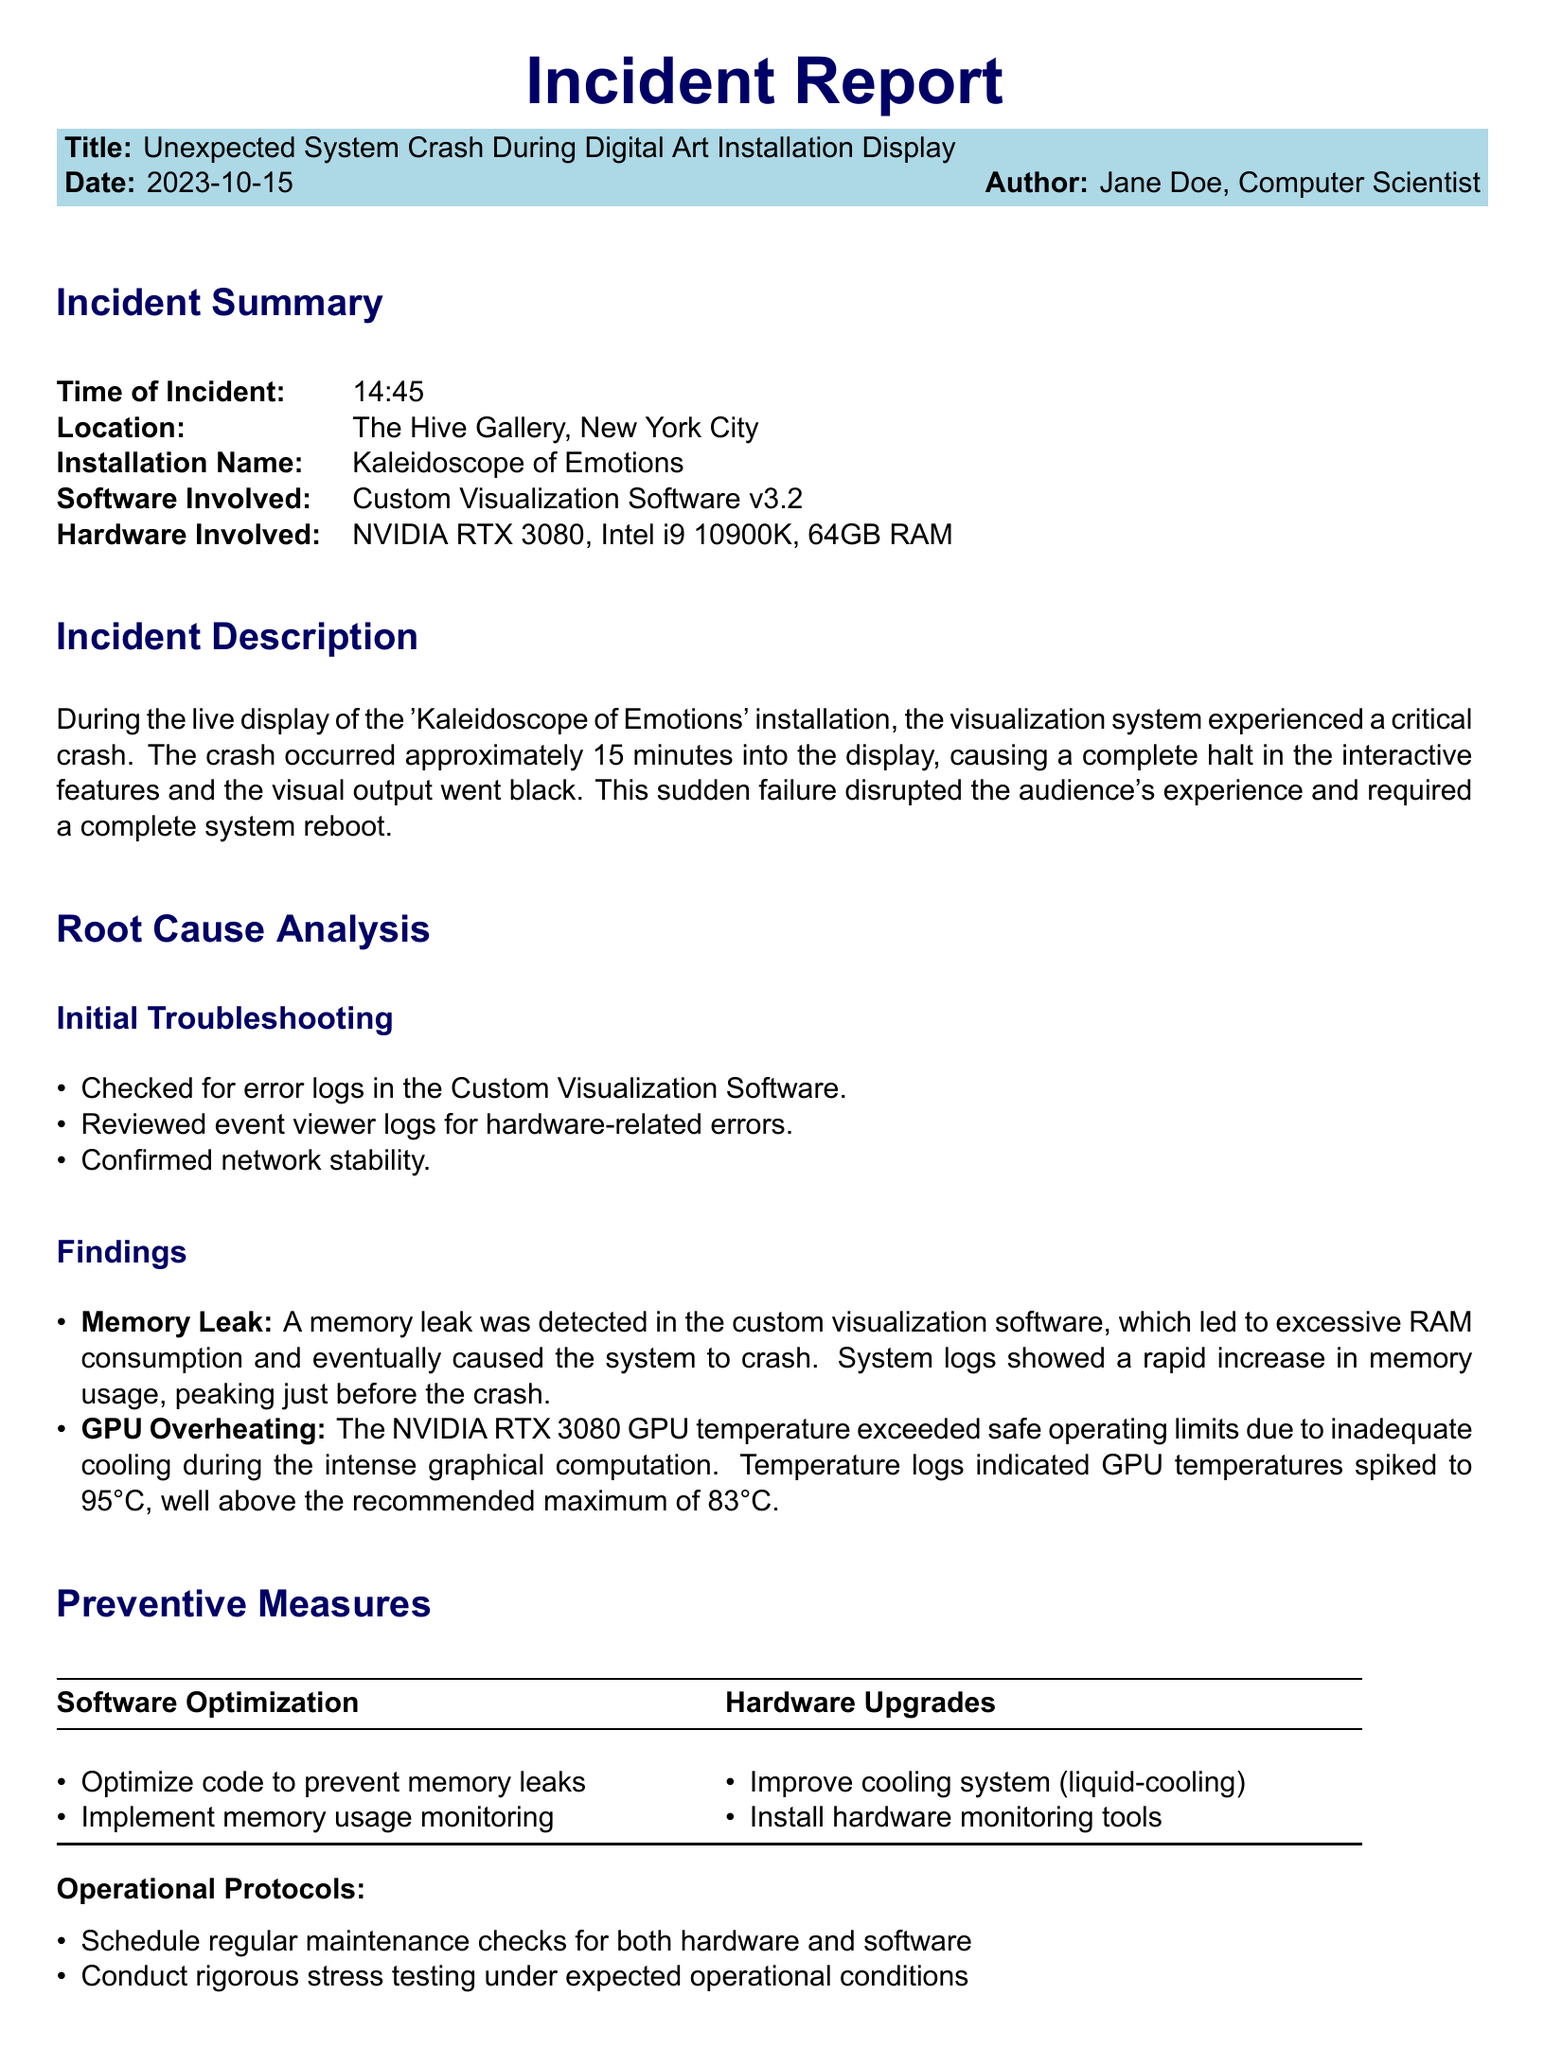What was the time of the incident? The time of the incident is explicitly stated in the incident summary section of the document.
Answer: 14:45 Who authored the incident report? The author of the incident report is listed in the document along with the date.
Answer: Jane Doe What caused the system crash? The primary causes of the system crash are detailed under the root cause analysis section.
Answer: Memory leak and GPU overheating What temperature did the GPU peak at during the crash? The maximum GPU temperature reached during the incident is provided in the findings of the root cause analysis.
Answer: 95°C What type of cooling system is suggested as a preventive measure? Suggestions for hardware upgrades are included in the preventive measures section.
Answer: Liquid-cooling Where did the incident take place? The location of the incident is provided in the incident summary.
Answer: The Hive Gallery, New York City What date did the incident occur? The date of the incident is clearly indicated at the top of the document.
Answer: 2023-10-15 What software version was involved in the incident? The software version mentioned in the incident summary provides insight into the system used.
Answer: Custom Visualization Software v3.2 What is one operational protocol suggested for future prevention? The document lists operational protocols to maintain functionality after the incident.
Answer: Schedule regular maintenance checks 